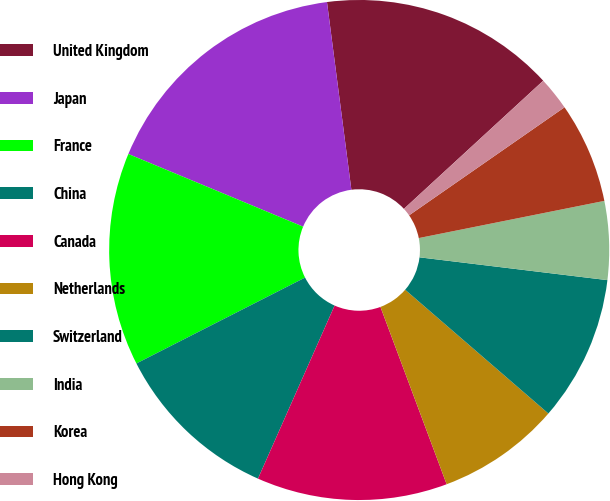Convert chart to OTSL. <chart><loc_0><loc_0><loc_500><loc_500><pie_chart><fcel>United Kingdom<fcel>Japan<fcel>France<fcel>China<fcel>Canada<fcel>Netherlands<fcel>Switzerland<fcel>India<fcel>Korea<fcel>Hong Kong<nl><fcel>15.22%<fcel>16.67%<fcel>13.77%<fcel>10.87%<fcel>12.32%<fcel>7.97%<fcel>9.42%<fcel>5.07%<fcel>6.52%<fcel>2.17%<nl></chart> 